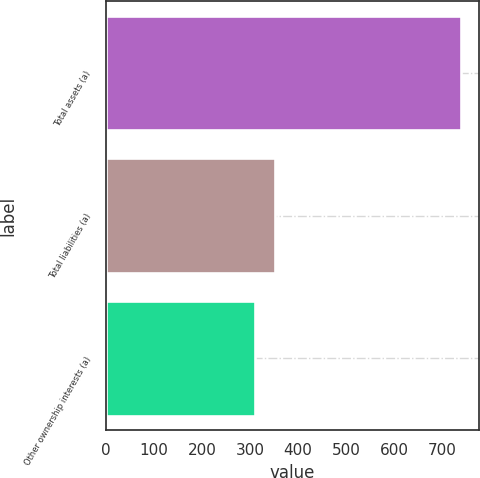Convert chart. <chart><loc_0><loc_0><loc_500><loc_500><bar_chart><fcel>Total assets (a)<fcel>Total liabilities (a)<fcel>Other ownership interests (a)<nl><fcel>740<fcel>353<fcel>310<nl></chart> 